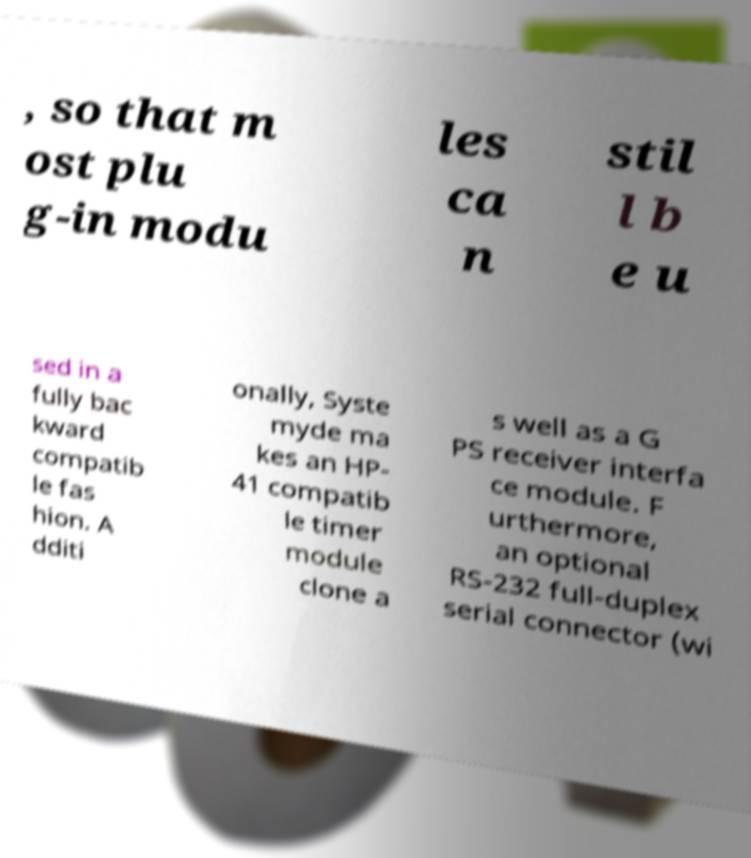Please read and relay the text visible in this image. What does it say? , so that m ost plu g-in modu les ca n stil l b e u sed in a fully bac kward compatib le fas hion. A dditi onally, Syste myde ma kes an HP- 41 compatib le timer module clone a s well as a G PS receiver interfa ce module. F urthermore, an optional RS-232 full-duplex serial connector (wi 